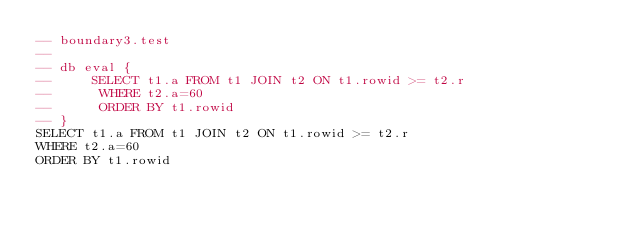Convert code to text. <code><loc_0><loc_0><loc_500><loc_500><_SQL_>-- boundary3.test
-- 
-- db eval {
--     SELECT t1.a FROM t1 JOIN t2 ON t1.rowid >= t2.r
--      WHERE t2.a=60
--      ORDER BY t1.rowid
-- }
SELECT t1.a FROM t1 JOIN t2 ON t1.rowid >= t2.r
WHERE t2.a=60
ORDER BY t1.rowid</code> 